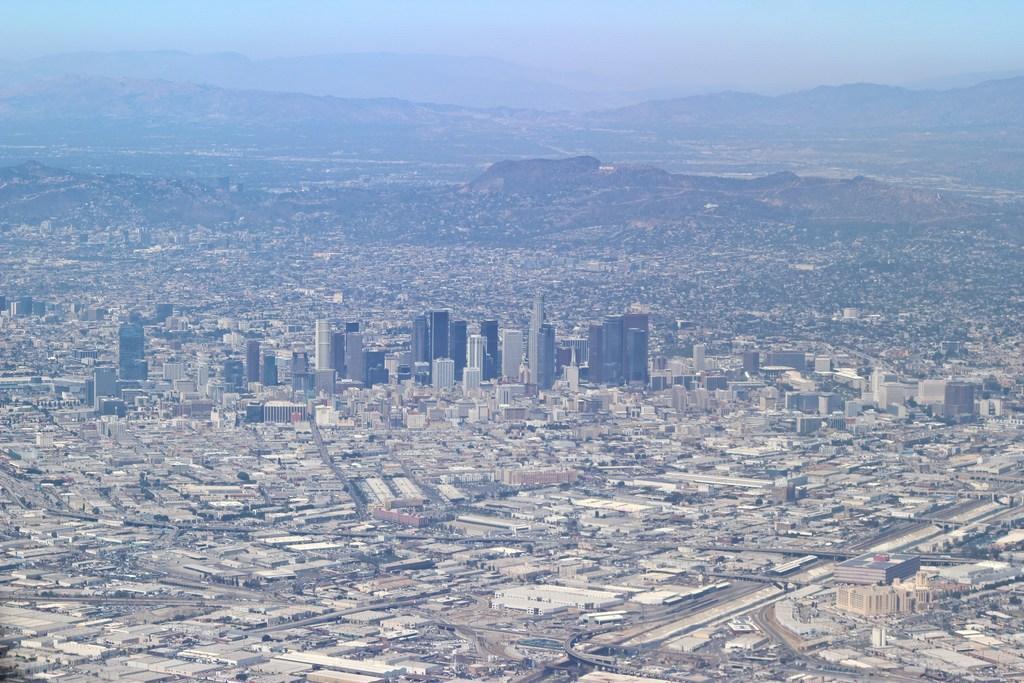Describe this image in one or two sentences. In this image we can see a group of buildings and some roads. On the backside we can see the hills and the sky which looks cloudy. 